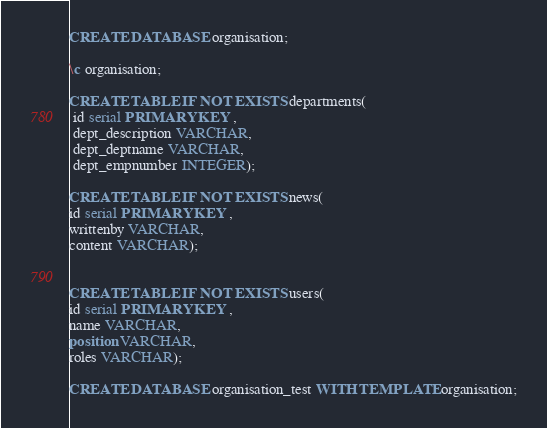Convert code to text. <code><loc_0><loc_0><loc_500><loc_500><_SQL_>CREATE DATABASE organisation;

\c organisation;

CREATE TABLE IF NOT EXISTS departments(
 id serial PRIMARY KEY ,
 dept_description VARCHAR,
 dept_deptname VARCHAR,
 dept_empnumber INTEGER);

CREATE TABLE IF NOT EXISTS news(
id serial PRIMARY KEY ,
writtenby VARCHAR,
content VARCHAR);


CREATE TABLE IF NOT EXISTS users(
id serial PRIMARY KEY ,
name VARCHAR,
position VARCHAR,
roles VARCHAR);

CREATE DATABASE organisation_test WITH TEMPLATE organisation;
</code> 